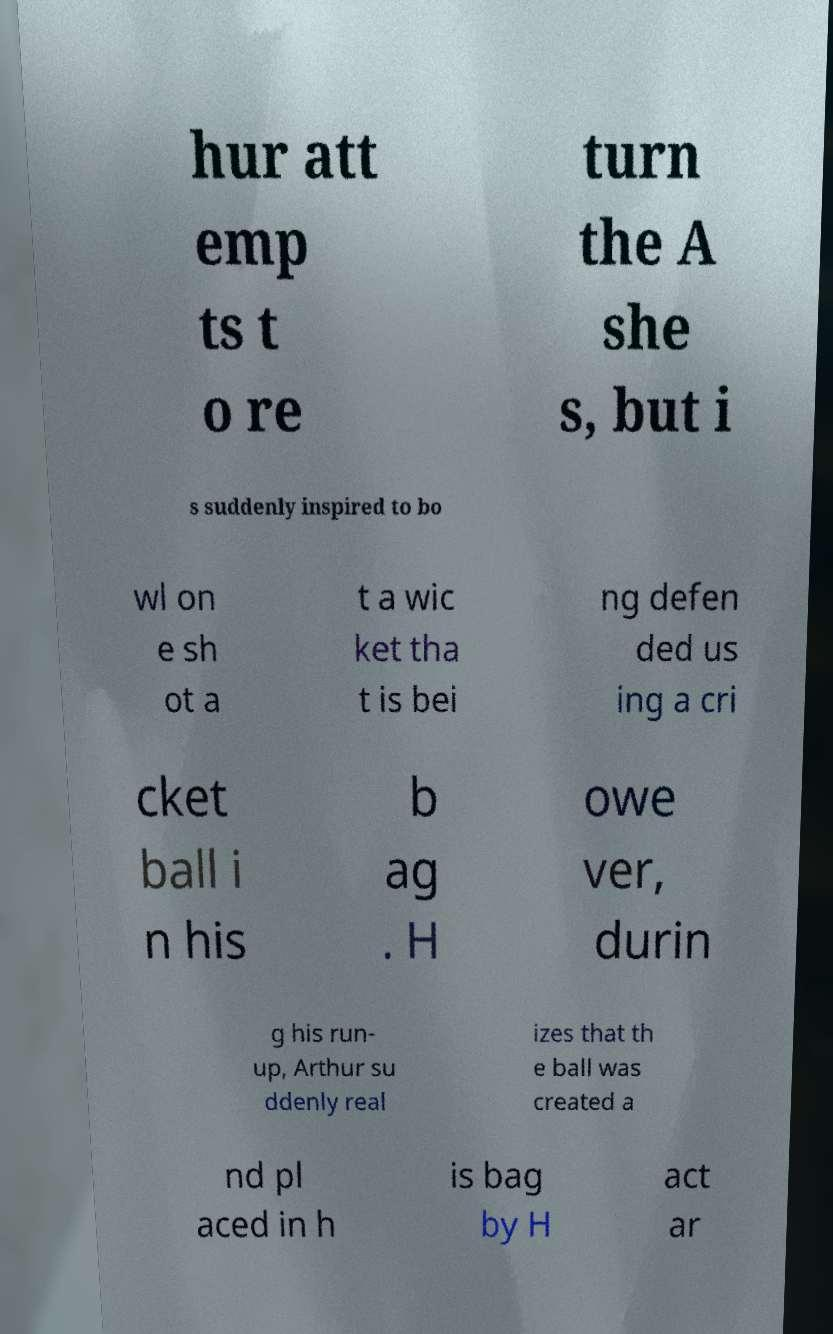Can you read and provide the text displayed in the image?This photo seems to have some interesting text. Can you extract and type it out for me? hur att emp ts t o re turn the A she s, but i s suddenly inspired to bo wl on e sh ot a t a wic ket tha t is bei ng defen ded us ing a cri cket ball i n his b ag . H owe ver, durin g his run- up, Arthur su ddenly real izes that th e ball was created a nd pl aced in h is bag by H act ar 